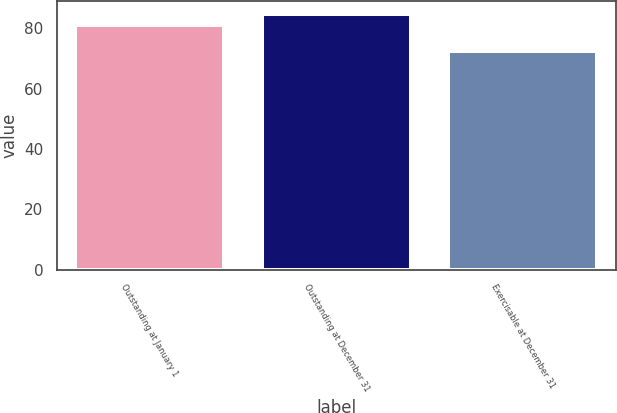Convert chart. <chart><loc_0><loc_0><loc_500><loc_500><bar_chart><fcel>Outstanding at January 1<fcel>Outstanding at December 31<fcel>Exercisable at December 31<nl><fcel>81.11<fcel>84.85<fcel>72.4<nl></chart> 